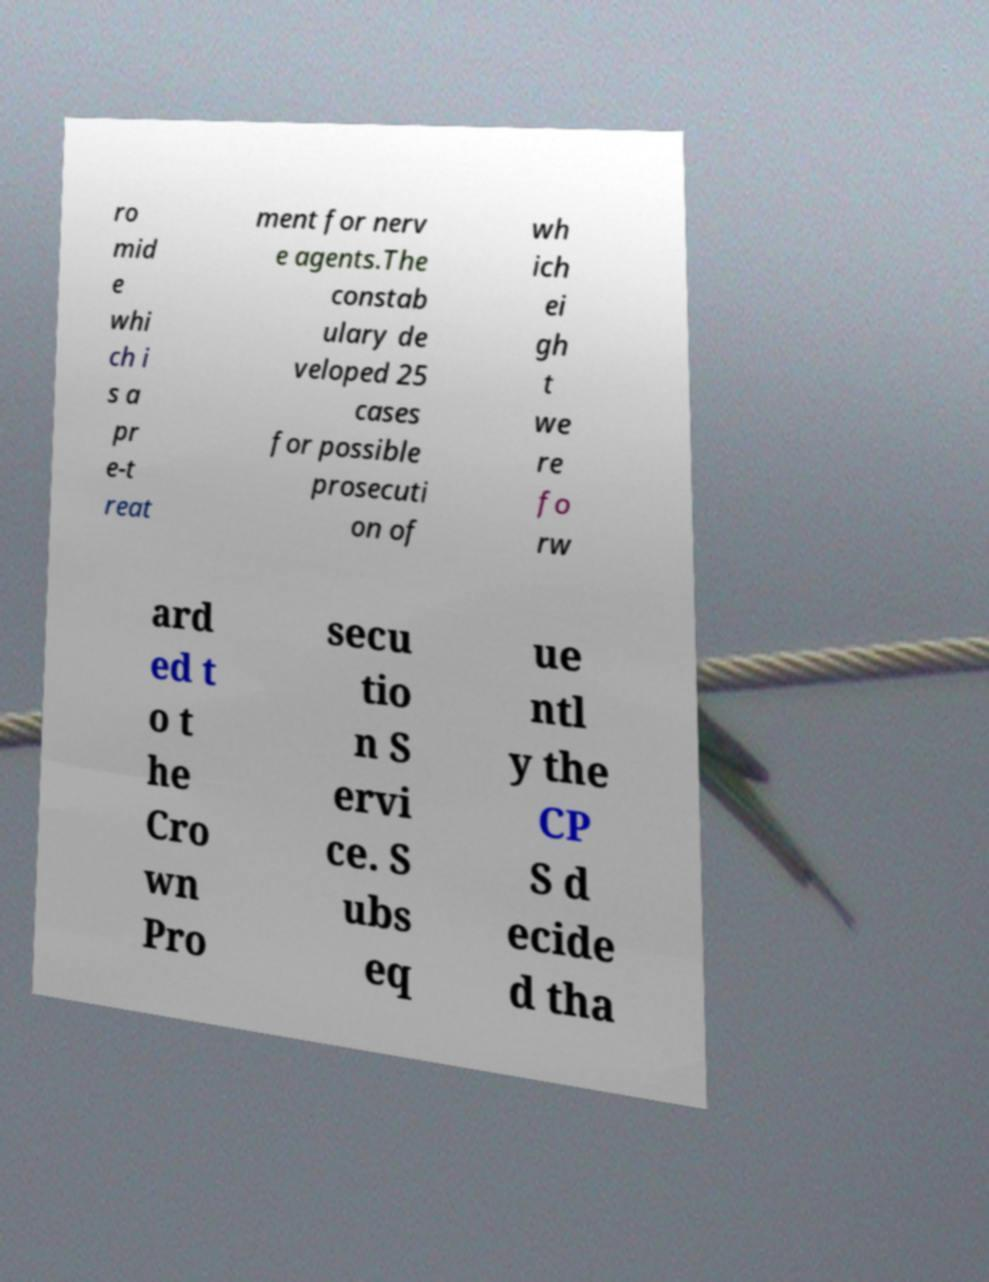Can you accurately transcribe the text from the provided image for me? ro mid e whi ch i s a pr e-t reat ment for nerv e agents.The constab ulary de veloped 25 cases for possible prosecuti on of wh ich ei gh t we re fo rw ard ed t o t he Cro wn Pro secu tio n S ervi ce. S ubs eq ue ntl y the CP S d ecide d tha 